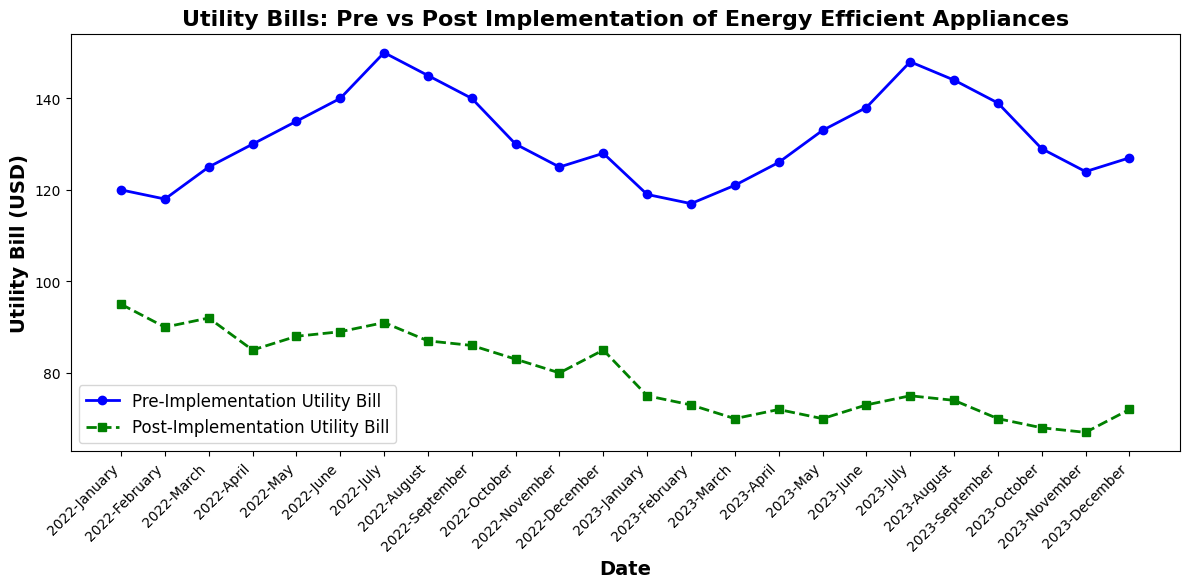What month saw the highest reduction in utility bills after implementing energy-efficient appliances? To find the highest reduction, we need to calculate the differences between the pre- and post-implementation bills for each month and determine the maximum. The highest reduction is observed in January 2023 with 119 (pre) - 75 (post) = 44 USD.
Answer: January 2023 How much did the utility bill decrease on average per month from January to December 2023 compared to pre-implementation? Calculate the average reduction for each month from January to December 2023 by summing up the differences (119-75 + 117-73 + 121-70 + 126-72 + 133-70 + 138-73 + 148-75 + 144-74 + 139-70 + 129-68 + 124-67 + 127-72) and then dividing by 12. The sum of reductions is 474, so the average decrease is 474/12 = 39.5 USD.
Answer: 39.5 USD Which month had the smallest difference between pre- and post-implementation utility bills? By checking the differences month-by-month, we find that June 2022 had the smallest difference with 140 (pre) - 89 (post) = 51 USD.
Answer: June 2022 When was the post-implementation utility bill the lowest, and what was the amount? Review each post-implementation bill and identify the lowest one. It occurs in November 2023 with a bill of 67 USD.
Answer: November 2023, 67 USD How do the pre- and post-implementation utility bills compare in terms of general trend over the two years? Observe the overall trend. The pre-implementation trend shows mostly higher bills with fluctuations, while the post-implementation trend reveals consistently lower and more stable bills.
Answer: Pre-implementation: higher and fluctuating, Post-implementation: lower and stable What is the combined utility bill for both pre- and post-implementation for July 2022? Sum the pre- and post-implementation bills for July 2022: 150 (pre) + 91 (post) = 241 USD.
Answer: 241 USD Which month consistently showed a decrease in utility bills post-implementation for both 2022 and 2023? By checking both years, we see that November consistently showed a decrease: 125 (pre-2022) - 80 (post-2022) = 45 USD, and 124 (pre-2023) - 67 (post-2023) = 57 USD.
Answer: November What is the total reduction in utility bills from June to August 2023 compared to pre-implementation during the same months in 2022? Calculate the total reduction by summing the differences for June, July, and August of both years: (140-89) + (150-91) + (145-87) + (138-73) + (148-75) + (144-74) = 156 + 76 + 58 = 290 USD.
Answer: 290 USD By how much did the utility bill decrease from December 2022 to January 2023 after post-implementation? Subtract the post-implementation bill of January 2023 from December 2022: 85 - 75 = 10 USD.
Answer: 10 USD 